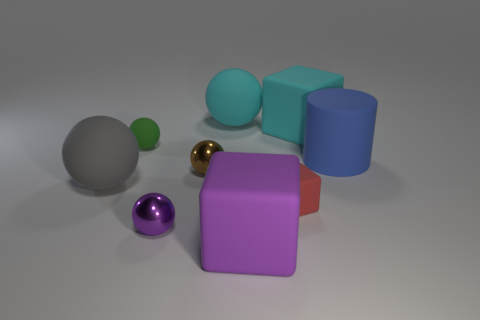Subtract all purple spheres. How many spheres are left? 4 Subtract all small matte spheres. How many spheres are left? 4 Subtract all blue spheres. Subtract all cyan cubes. How many spheres are left? 5 Subtract all cylinders. How many objects are left? 8 Add 3 small red matte cubes. How many small red matte cubes exist? 4 Subtract 0 red cylinders. How many objects are left? 9 Subtract all big brown shiny things. Subtract all matte balls. How many objects are left? 6 Add 3 cyan rubber balls. How many cyan rubber balls are left? 4 